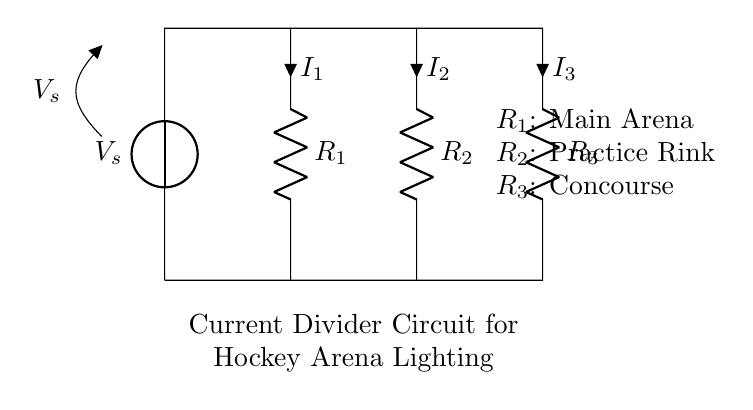What is the source voltage in this circuit? The source voltage is denoted as V_s in the diagram, indicating the voltage supplied to the circuit.
Answer: V_s What are the three resistors in the circuit? The circuit contains three resistors: R_1 represents the main arena, R_2 represents the practice rink, and R_3 represents the concourse.
Answer: R_1, R_2, R_3 What is the current through R_2? The current flowing through R_2 is labeled as I_2 in the circuit, indicating the amount of current that passes through this resistor.
Answer: I_2 Why does current divide in this circuit? Current divides in this circuit because of the presence of parallel resistors; each resistor has a different resistance which affects how much current flows through each path. The total current from the source is divided amongst the parallel branches based on their resistances.
Answer: Due to parallel resistors Which component has the highest resistance? R_1 is indicated as the main arena resistor, which usually would have a higher resistance compared to R_2 and R_3, typically designed to handle more load.
Answer: R_1 How would increasing R_3 affect the current in the circuit? Increasing R_3 would increase its resistance, which would decrease the total current flowing through it according to the current divider rule. Consequently, more current would flow through the other resistors, R_1 and R_2, since the total current drawn from the source remains constant.
Answer: It would decrease current in R_3 